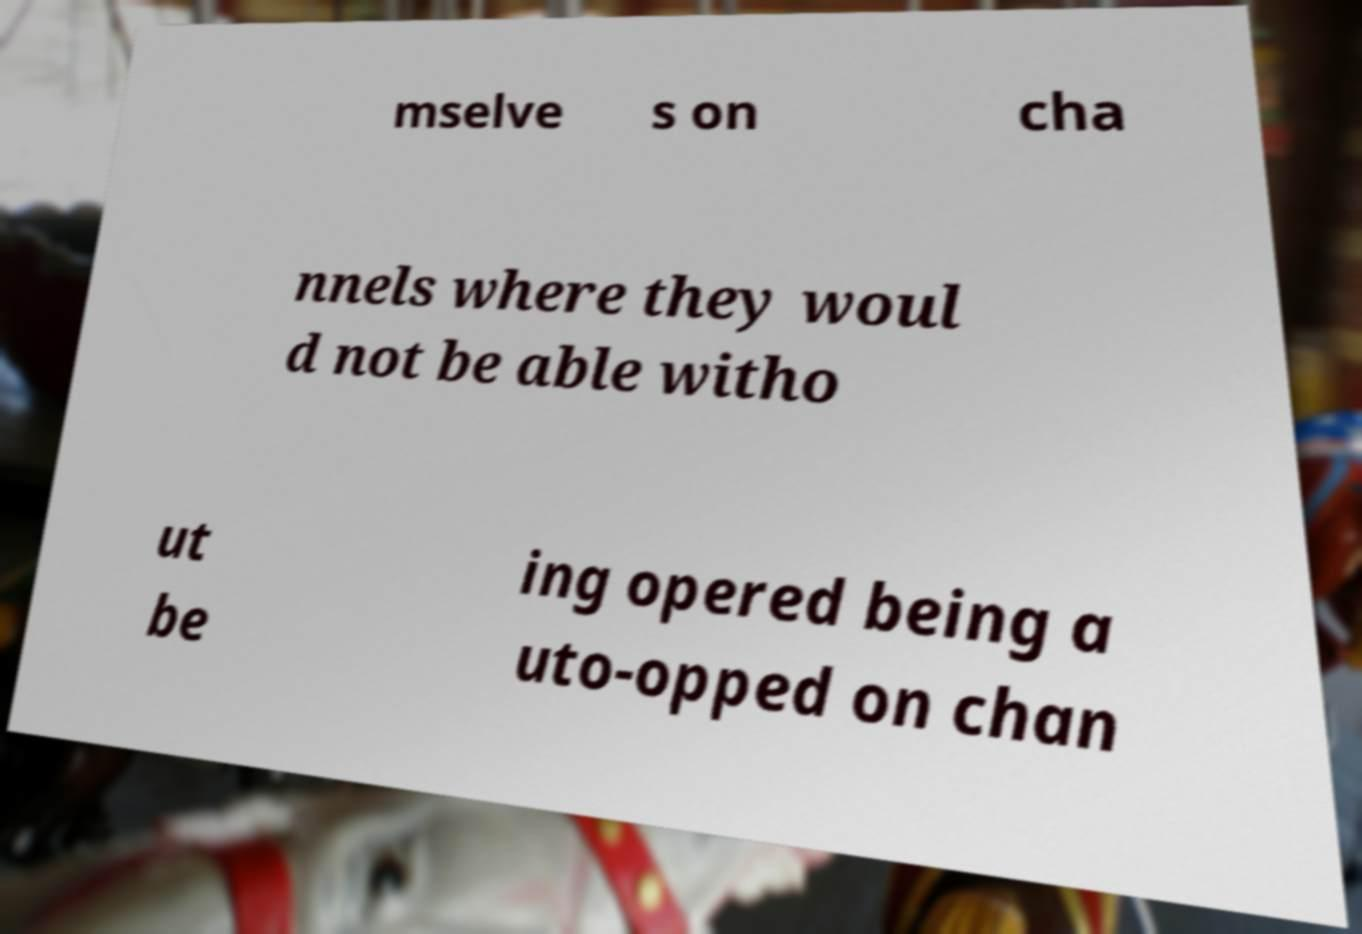For documentation purposes, I need the text within this image transcribed. Could you provide that? mselve s on cha nnels where they woul d not be able witho ut be ing opered being a uto-opped on chan 